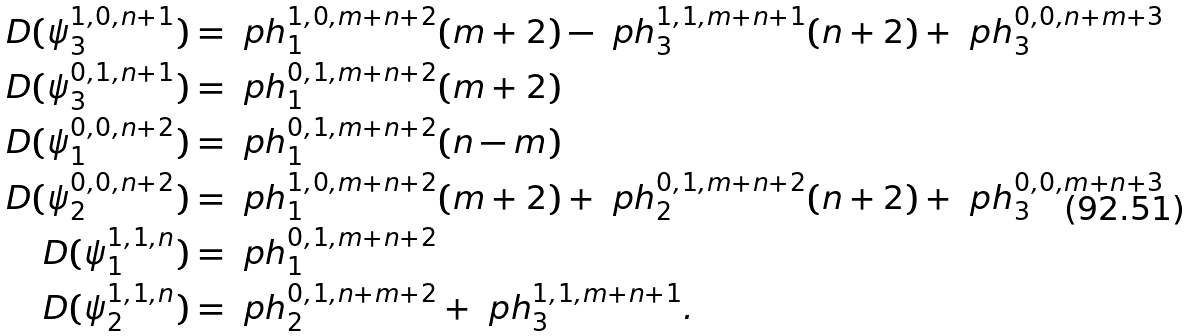<formula> <loc_0><loc_0><loc_500><loc_500>D ( \psi ^ { 1 , 0 , n + 1 } _ { 3 } ) & = \ p h ^ { 1 , 0 , m + n + 2 } _ { 1 } ( m + 2 ) - \ p h ^ { 1 , 1 , m + n + 1 } _ { 3 } ( n + 2 ) + \ p h ^ { 0 , 0 , n + m + 3 } _ { 3 } \\ D ( \psi ^ { 0 , 1 , n + 1 } _ { 3 } ) & = \ p h ^ { 0 , 1 , m + n + 2 } _ { 1 } ( m + 2 ) \\ D ( \psi ^ { 0 , 0 , n + 2 } _ { 1 } ) & = \ p h ^ { 0 , 1 , m + n + 2 } _ { 1 } ( n - m ) \\ D ( \psi ^ { 0 , 0 , n + 2 } _ { 2 } ) & = \ p h ^ { 1 , 0 , m + n + 2 } _ { 1 } ( m + 2 ) + \ p h ^ { 0 , 1 , m + n + 2 } _ { 2 } ( n + 2 ) + \ p h ^ { 0 , 0 , m + n + 3 } _ { 3 } \\ D ( \psi ^ { 1 , 1 , n } _ { 1 } ) & = \ p h ^ { 0 , 1 , m + n + 2 } _ { 1 } \\ D ( \psi ^ { 1 , 1 , n } _ { 2 } ) & = \ p h ^ { 0 , 1 , n + m + 2 } _ { 2 } + \ p h ^ { 1 , 1 , m + n + 1 } _ { 3 } .</formula> 